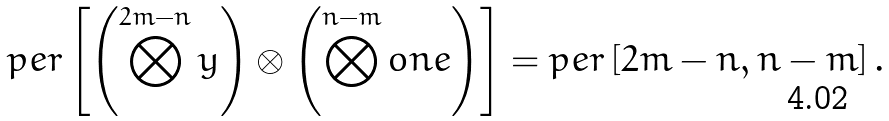<formula> <loc_0><loc_0><loc_500><loc_500>p e r \left [ \left ( \bigotimes ^ { 2 m - n } y \right ) \otimes \left ( \bigotimes ^ { n - m } o n e \right ) \right ] = p e r \left [ 2 m - n , n - m \right ] .</formula> 